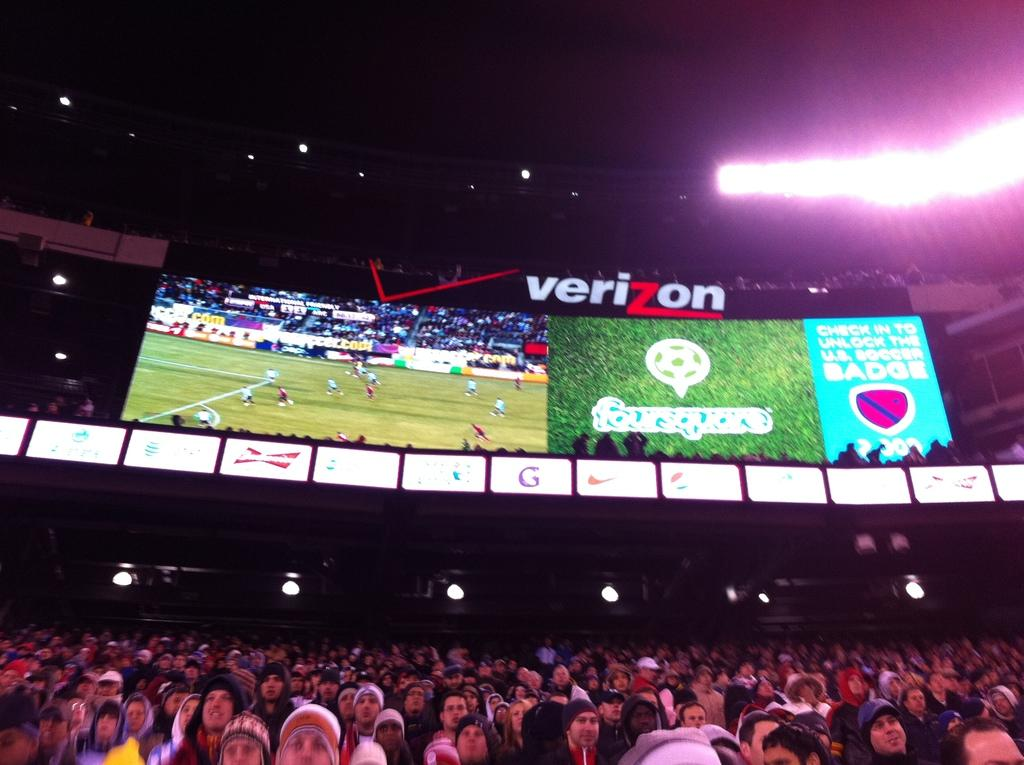<image>
Render a clear and concise summary of the photo. A stadium of people are sitting under a Verizon scoreboard watching a game. 